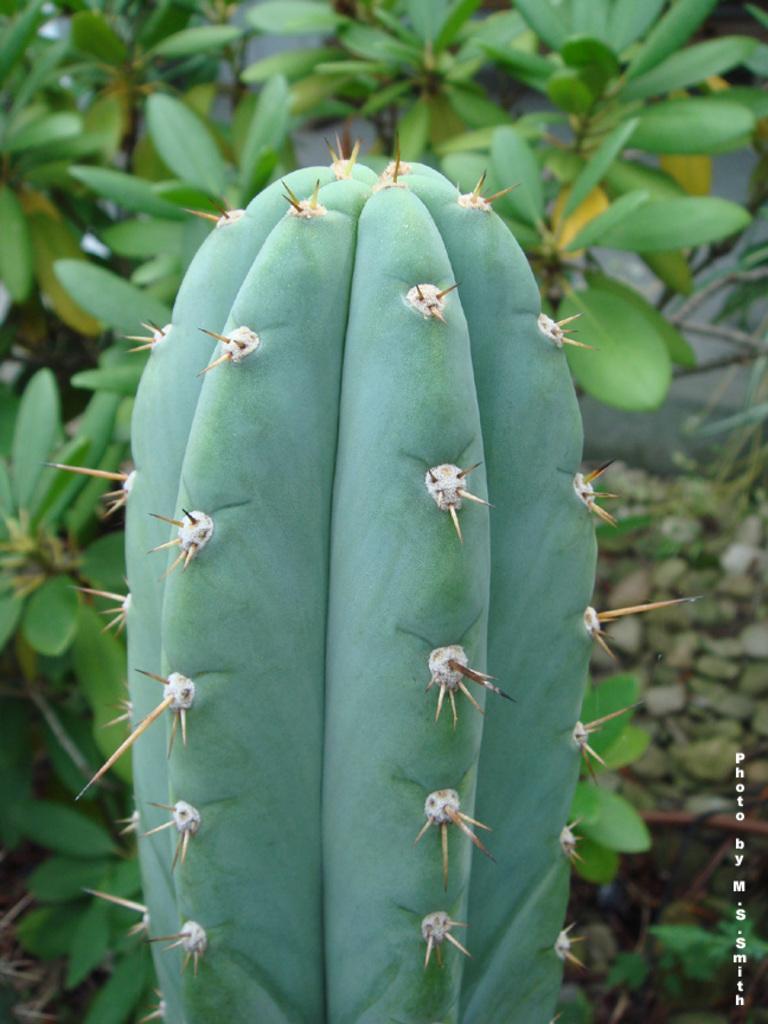Could you give a brief overview of what you see in this image? In this image we can see a cactus and there are some plants in the background and we can see some text on the image. 